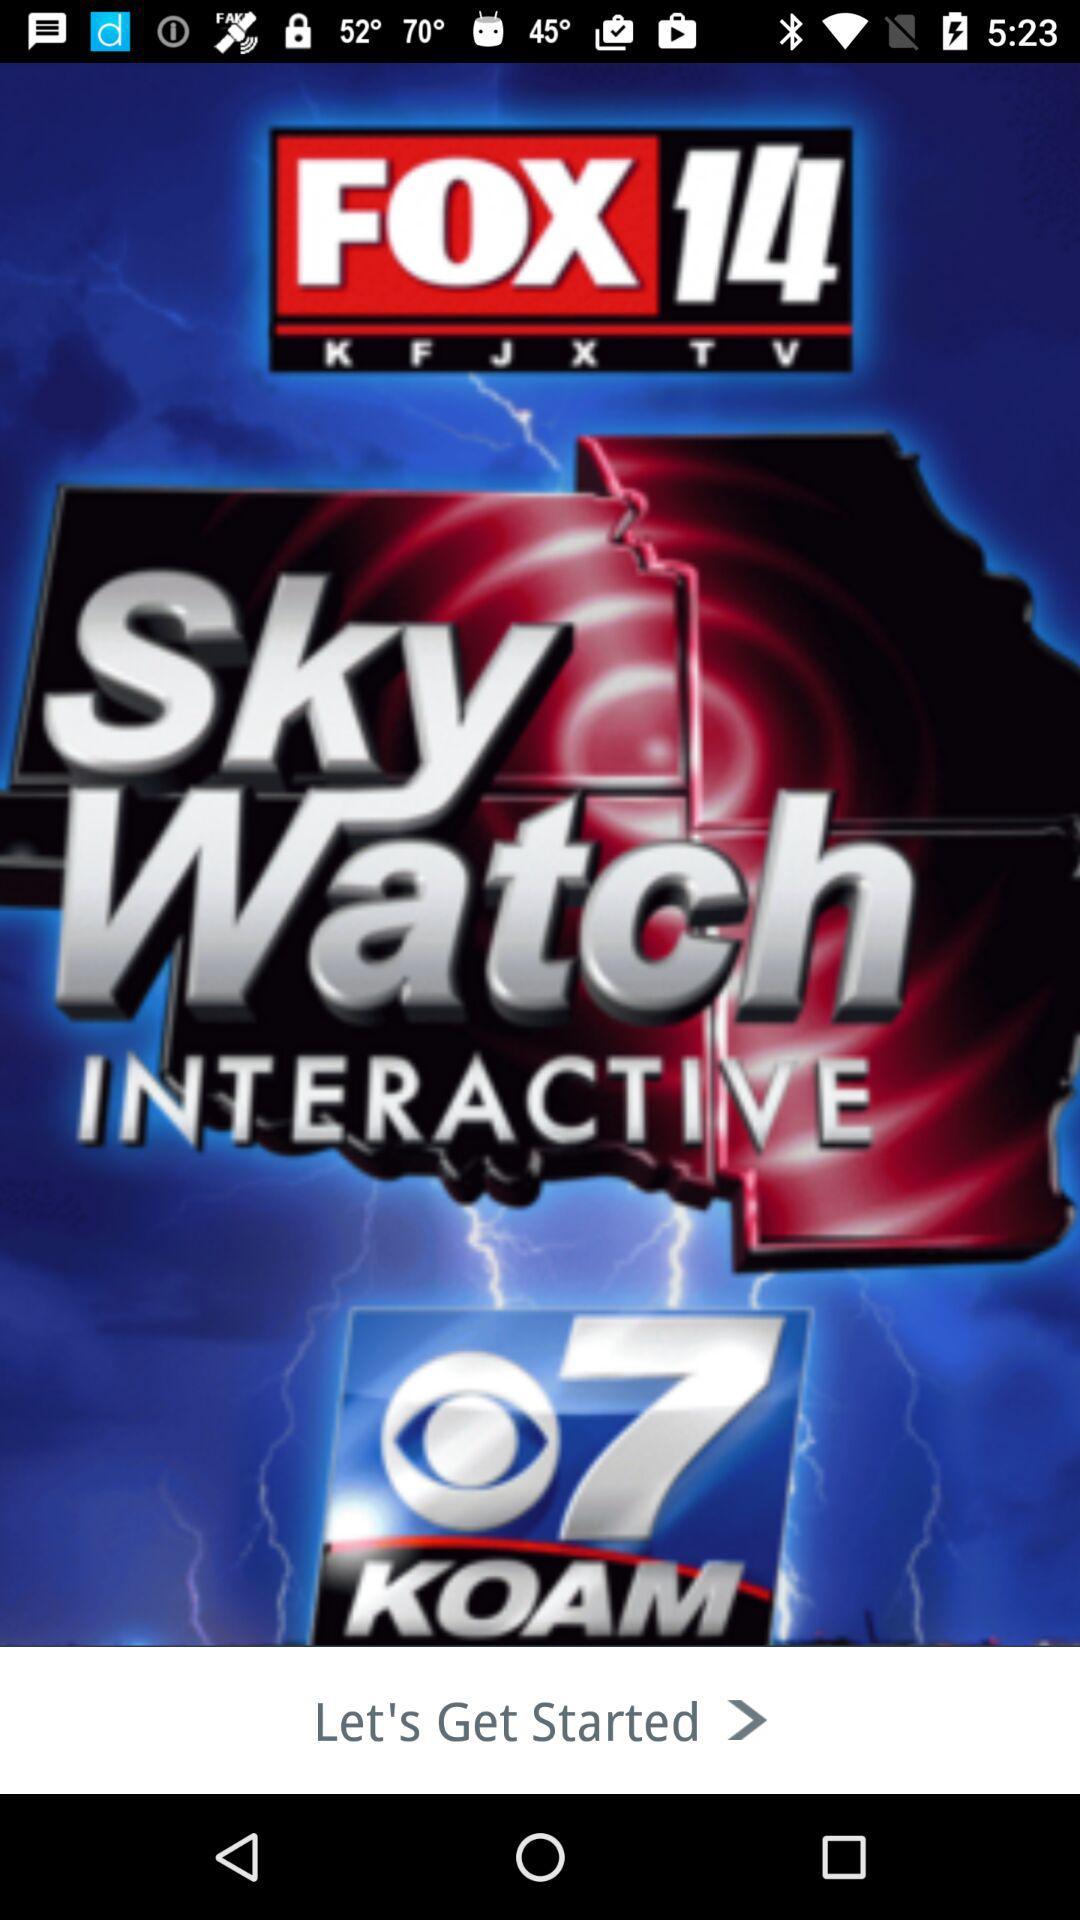What is the name of the application? The name of the application is "FOX 14 KFJX TV". 